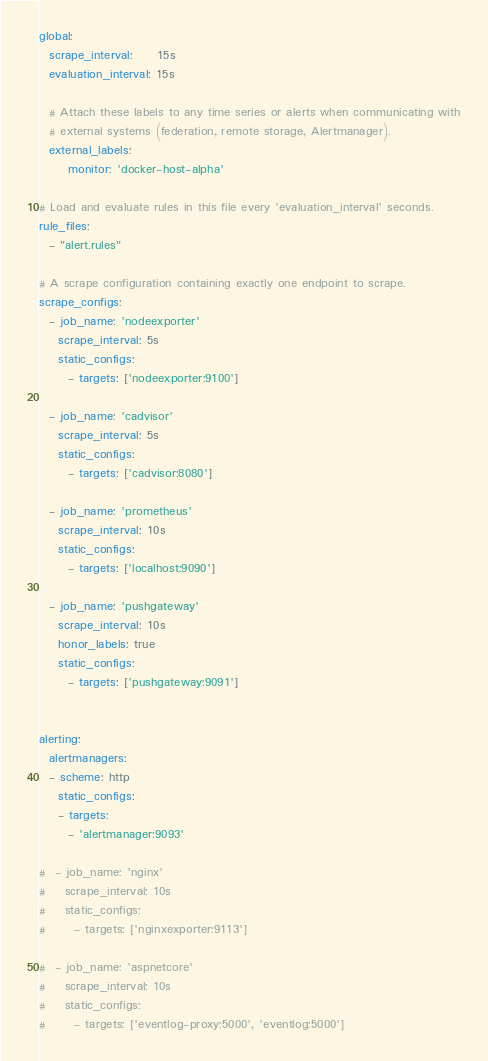<code> <loc_0><loc_0><loc_500><loc_500><_YAML_>global:
  scrape_interval:     15s
  evaluation_interval: 15s

  # Attach these labels to any time series or alerts when communicating with
  # external systems (federation, remote storage, Alertmanager).
  external_labels:
      monitor: 'docker-host-alpha'

# Load and evaluate rules in this file every 'evaluation_interval' seconds.
rule_files:
  - "alert.rules"

# A scrape configuration containing exactly one endpoint to scrape.
scrape_configs:
  - job_name: 'nodeexporter'
    scrape_interval: 5s
    static_configs:
      - targets: ['nodeexporter:9100']

  - job_name: 'cadvisor'
    scrape_interval: 5s
    static_configs:
      - targets: ['cadvisor:8080']

  - job_name: 'prometheus'
    scrape_interval: 10s
    static_configs:
      - targets: ['localhost:9090']

  - job_name: 'pushgateway'
    scrape_interval: 10s
    honor_labels: true
    static_configs:
      - targets: ['pushgateway:9091']


alerting:
  alertmanagers:
  - scheme: http
    static_configs:
    - targets: 
      - 'alertmanager:9093'

#  - job_name: 'nginx'
#    scrape_interval: 10s
#    static_configs:
#      - targets: ['nginxexporter:9113']

#  - job_name: 'aspnetcore'
#    scrape_interval: 10s
#    static_configs:
#      - targets: ['eventlog-proxy:5000', 'eventlog:5000']
</code> 